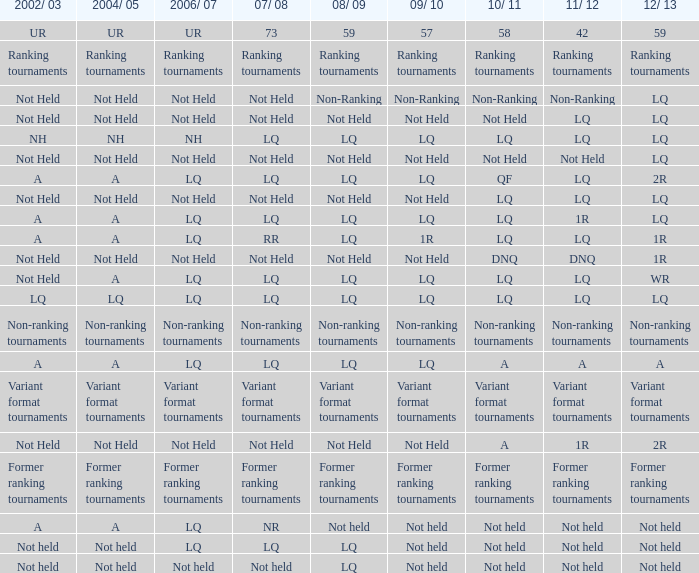Name the 2009/10 with 2011/12 of a LQ. 